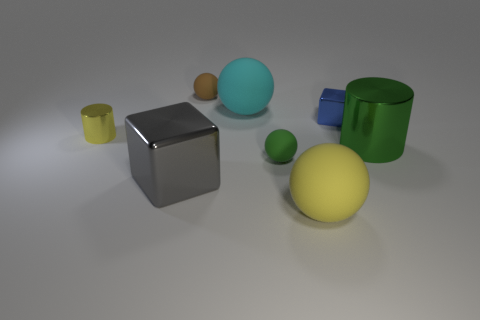Subtract all small green spheres. How many spheres are left? 3 Subtract all yellow balls. How many balls are left? 3 Subtract all gray spheres. Subtract all red cylinders. How many spheres are left? 4 Add 1 blue metallic cubes. How many objects exist? 9 Subtract all cylinders. How many objects are left? 6 Add 3 metal blocks. How many metal blocks are left? 5 Add 5 small green spheres. How many small green spheres exist? 6 Subtract 0 cyan cylinders. How many objects are left? 8 Subtract all tiny yellow shiny cylinders. Subtract all small metal objects. How many objects are left? 5 